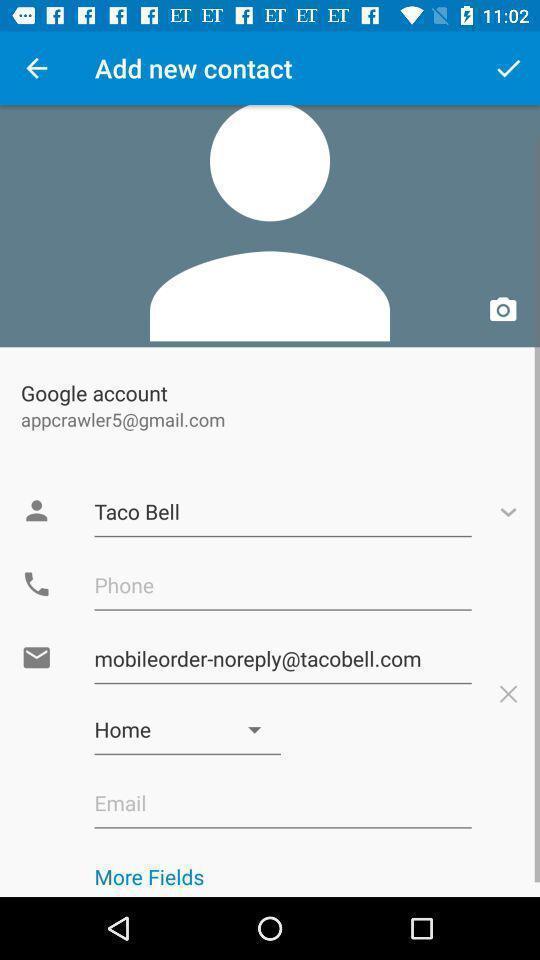Give me a narrative description of this picture. Page showing personal details in a contacts app. 